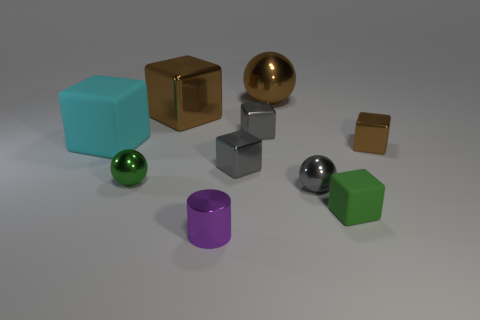Subtract all brown spheres. How many spheres are left? 2 Subtract all green cubes. How many cubes are left? 5 Subtract 3 cubes. How many cubes are left? 3 Subtract all small spheres. Subtract all small green metal spheres. How many objects are left? 7 Add 3 brown objects. How many brown objects are left? 6 Add 1 small gray spheres. How many small gray spheres exist? 2 Subtract 0 purple spheres. How many objects are left? 10 Subtract all spheres. How many objects are left? 7 Subtract all green cubes. Subtract all purple cylinders. How many cubes are left? 5 Subtract all gray blocks. How many brown spheres are left? 1 